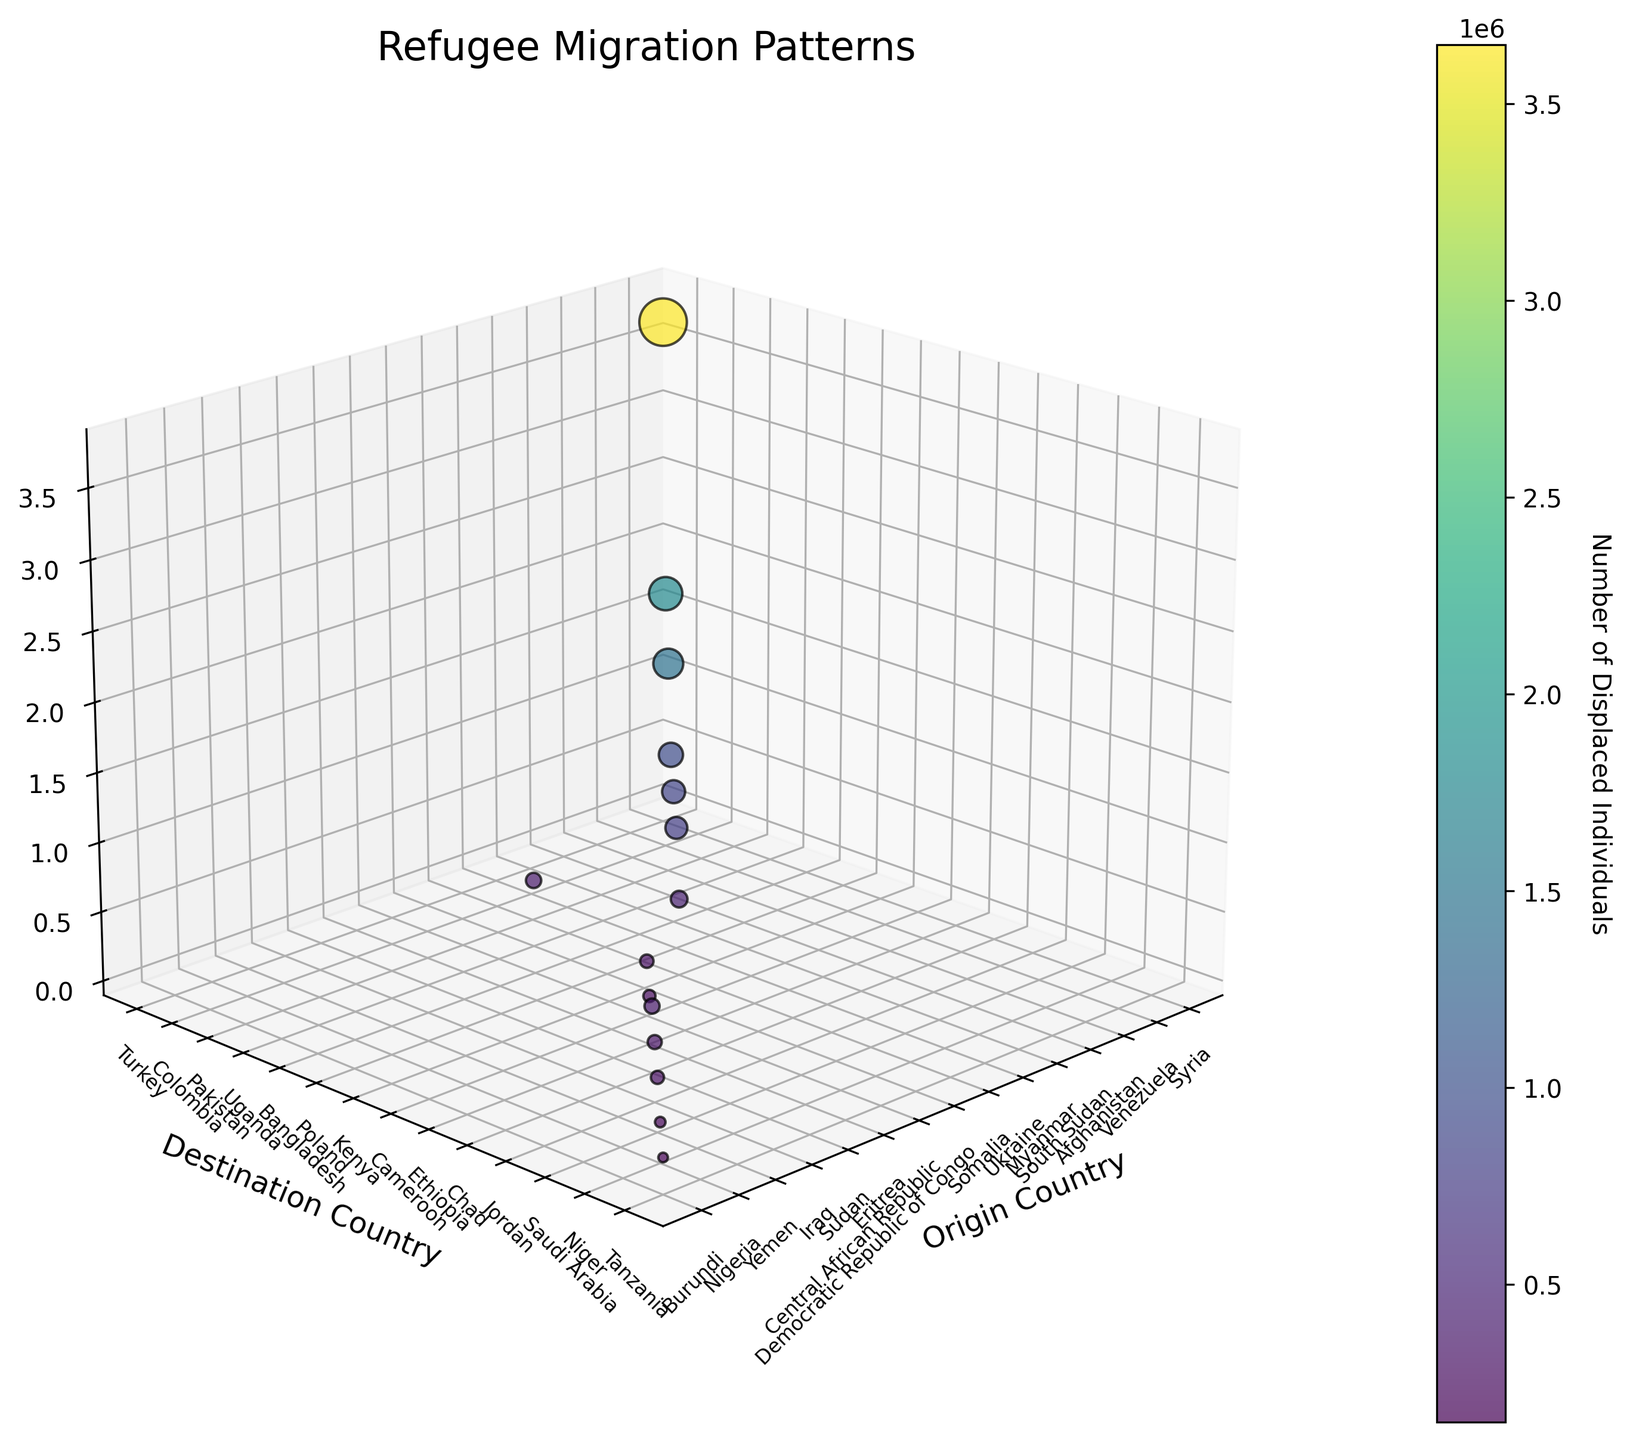Which country is represented as the origin with the highest number of displaced individuals? By observing the highest point on the z-axis, we can see that Syria has the highest number of displaced individuals, marked by the furthest point up the z-axis.
Answer: Syria What is the title of the 3D scatter plot? The title of the plot is located at the top center of the figure and is labelled as 'Refugee Migration Patterns'.
Answer: Refugee Migration Patterns Which destination country has received the most refugees? By looking at the destination with the highest point on the z-axis, Turkey stands out as the country receiving the most refugees.
Answer: Turkey What are the x-axis and y-axis labels? The x-axis and y-axis labels are 'Origin Country' and 'Destination Country' as indicated near the respective axes.
Answer: Origin Country and Destination Country How many destination countries have received over 1 million displaced individuals? By looking at the z-axis and counting all the data points above 1 million, we can identify three countries: Turkey, Colombia, and Pakistan.
Answer: Three Which refugee migration path represents the second-largest group of displaced individuals? By comparing the heights of the z-axis markers, the second-highest point appears to be from Venezuela to Colombia.
Answer: Venezuela to Colombia Is there a larger number of displaced individuals from Afghanistan to Pakistan than from Myanmar to Bangladesh? By comparing the z-axis heights for Afghanistan to Pakistan and Myanmar to Bangladesh, it is clear that 1,450,000 (Afghanistan to Pakistan) is larger than 860,000 (Myanmar to Bangladesh).
Answer: Yes Which origin country corresponds to the smallest size of the marker in the plot? By identifying the smallest marker size and checking its x-axis position, Burundi appears as the origin with 150,000 displaced individuals, the smallest number.
Answer: Burundi What is the range of values shown in the color bar legend? The color bar legend next to the scatter plot indicates a range from the minimum value of 150,000 to the maximum value of 3,650,000 displaced individuals.
Answer: 150,000 to 3,650,000 How many countries have both origins and destinations in the plot? By counting countries that appear both on the x-axis (origins) and y-axis (destinations), there are three: Uganda, Chad, and Tanzania.
Answer: Three 